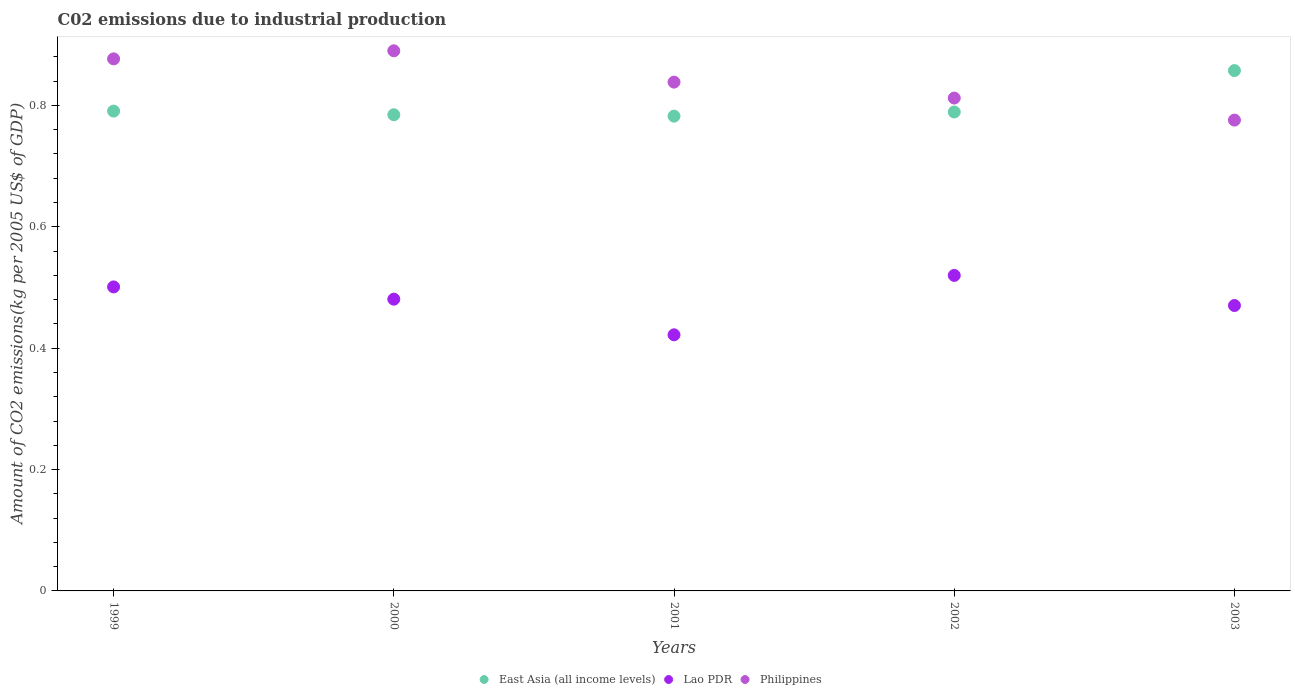Is the number of dotlines equal to the number of legend labels?
Make the answer very short. Yes. What is the amount of CO2 emitted due to industrial production in Philippines in 2000?
Your answer should be very brief. 0.89. Across all years, what is the maximum amount of CO2 emitted due to industrial production in East Asia (all income levels)?
Your answer should be compact. 0.86. Across all years, what is the minimum amount of CO2 emitted due to industrial production in Lao PDR?
Your response must be concise. 0.42. What is the total amount of CO2 emitted due to industrial production in Lao PDR in the graph?
Keep it short and to the point. 2.39. What is the difference between the amount of CO2 emitted due to industrial production in East Asia (all income levels) in 2000 and that in 2003?
Your response must be concise. -0.07. What is the difference between the amount of CO2 emitted due to industrial production in Lao PDR in 2002 and the amount of CO2 emitted due to industrial production in Philippines in 2000?
Offer a very short reply. -0.37. What is the average amount of CO2 emitted due to industrial production in Philippines per year?
Provide a short and direct response. 0.84. In the year 1999, what is the difference between the amount of CO2 emitted due to industrial production in Philippines and amount of CO2 emitted due to industrial production in East Asia (all income levels)?
Ensure brevity in your answer.  0.09. In how many years, is the amount of CO2 emitted due to industrial production in East Asia (all income levels) greater than 0.28 kg?
Your answer should be very brief. 5. What is the ratio of the amount of CO2 emitted due to industrial production in Philippines in 2000 to that in 2001?
Offer a very short reply. 1.06. Is the difference between the amount of CO2 emitted due to industrial production in Philippines in 2001 and 2002 greater than the difference between the amount of CO2 emitted due to industrial production in East Asia (all income levels) in 2001 and 2002?
Your answer should be compact. Yes. What is the difference between the highest and the second highest amount of CO2 emitted due to industrial production in East Asia (all income levels)?
Your answer should be very brief. 0.07. What is the difference between the highest and the lowest amount of CO2 emitted due to industrial production in East Asia (all income levels)?
Ensure brevity in your answer.  0.08. How many dotlines are there?
Your answer should be compact. 3. How many years are there in the graph?
Ensure brevity in your answer.  5. Are the values on the major ticks of Y-axis written in scientific E-notation?
Provide a short and direct response. No. Does the graph contain any zero values?
Offer a very short reply. No. Where does the legend appear in the graph?
Make the answer very short. Bottom center. How are the legend labels stacked?
Your answer should be compact. Horizontal. What is the title of the graph?
Keep it short and to the point. C02 emissions due to industrial production. What is the label or title of the X-axis?
Offer a terse response. Years. What is the label or title of the Y-axis?
Keep it short and to the point. Amount of CO2 emissions(kg per 2005 US$ of GDP). What is the Amount of CO2 emissions(kg per 2005 US$ of GDP) of East Asia (all income levels) in 1999?
Offer a very short reply. 0.79. What is the Amount of CO2 emissions(kg per 2005 US$ of GDP) of Lao PDR in 1999?
Provide a succinct answer. 0.5. What is the Amount of CO2 emissions(kg per 2005 US$ of GDP) of Philippines in 1999?
Your answer should be very brief. 0.88. What is the Amount of CO2 emissions(kg per 2005 US$ of GDP) of East Asia (all income levels) in 2000?
Offer a terse response. 0.78. What is the Amount of CO2 emissions(kg per 2005 US$ of GDP) in Lao PDR in 2000?
Give a very brief answer. 0.48. What is the Amount of CO2 emissions(kg per 2005 US$ of GDP) of Philippines in 2000?
Make the answer very short. 0.89. What is the Amount of CO2 emissions(kg per 2005 US$ of GDP) of East Asia (all income levels) in 2001?
Your answer should be very brief. 0.78. What is the Amount of CO2 emissions(kg per 2005 US$ of GDP) of Lao PDR in 2001?
Make the answer very short. 0.42. What is the Amount of CO2 emissions(kg per 2005 US$ of GDP) of Philippines in 2001?
Give a very brief answer. 0.84. What is the Amount of CO2 emissions(kg per 2005 US$ of GDP) of East Asia (all income levels) in 2002?
Your answer should be very brief. 0.79. What is the Amount of CO2 emissions(kg per 2005 US$ of GDP) in Lao PDR in 2002?
Your answer should be very brief. 0.52. What is the Amount of CO2 emissions(kg per 2005 US$ of GDP) of Philippines in 2002?
Give a very brief answer. 0.81. What is the Amount of CO2 emissions(kg per 2005 US$ of GDP) of East Asia (all income levels) in 2003?
Offer a terse response. 0.86. What is the Amount of CO2 emissions(kg per 2005 US$ of GDP) in Lao PDR in 2003?
Give a very brief answer. 0.47. What is the Amount of CO2 emissions(kg per 2005 US$ of GDP) in Philippines in 2003?
Make the answer very short. 0.78. Across all years, what is the maximum Amount of CO2 emissions(kg per 2005 US$ of GDP) in East Asia (all income levels)?
Your answer should be very brief. 0.86. Across all years, what is the maximum Amount of CO2 emissions(kg per 2005 US$ of GDP) of Lao PDR?
Offer a terse response. 0.52. Across all years, what is the maximum Amount of CO2 emissions(kg per 2005 US$ of GDP) in Philippines?
Your answer should be very brief. 0.89. Across all years, what is the minimum Amount of CO2 emissions(kg per 2005 US$ of GDP) in East Asia (all income levels)?
Your answer should be very brief. 0.78. Across all years, what is the minimum Amount of CO2 emissions(kg per 2005 US$ of GDP) of Lao PDR?
Your answer should be compact. 0.42. Across all years, what is the minimum Amount of CO2 emissions(kg per 2005 US$ of GDP) of Philippines?
Offer a very short reply. 0.78. What is the total Amount of CO2 emissions(kg per 2005 US$ of GDP) of East Asia (all income levels) in the graph?
Give a very brief answer. 4. What is the total Amount of CO2 emissions(kg per 2005 US$ of GDP) of Lao PDR in the graph?
Your answer should be very brief. 2.39. What is the total Amount of CO2 emissions(kg per 2005 US$ of GDP) of Philippines in the graph?
Give a very brief answer. 4.19. What is the difference between the Amount of CO2 emissions(kg per 2005 US$ of GDP) of East Asia (all income levels) in 1999 and that in 2000?
Offer a very short reply. 0.01. What is the difference between the Amount of CO2 emissions(kg per 2005 US$ of GDP) of Lao PDR in 1999 and that in 2000?
Ensure brevity in your answer.  0.02. What is the difference between the Amount of CO2 emissions(kg per 2005 US$ of GDP) of Philippines in 1999 and that in 2000?
Offer a very short reply. -0.01. What is the difference between the Amount of CO2 emissions(kg per 2005 US$ of GDP) of East Asia (all income levels) in 1999 and that in 2001?
Provide a succinct answer. 0.01. What is the difference between the Amount of CO2 emissions(kg per 2005 US$ of GDP) in Lao PDR in 1999 and that in 2001?
Offer a very short reply. 0.08. What is the difference between the Amount of CO2 emissions(kg per 2005 US$ of GDP) of Philippines in 1999 and that in 2001?
Provide a short and direct response. 0.04. What is the difference between the Amount of CO2 emissions(kg per 2005 US$ of GDP) of East Asia (all income levels) in 1999 and that in 2002?
Your response must be concise. 0. What is the difference between the Amount of CO2 emissions(kg per 2005 US$ of GDP) of Lao PDR in 1999 and that in 2002?
Your answer should be very brief. -0.02. What is the difference between the Amount of CO2 emissions(kg per 2005 US$ of GDP) of Philippines in 1999 and that in 2002?
Your answer should be compact. 0.06. What is the difference between the Amount of CO2 emissions(kg per 2005 US$ of GDP) of East Asia (all income levels) in 1999 and that in 2003?
Provide a short and direct response. -0.07. What is the difference between the Amount of CO2 emissions(kg per 2005 US$ of GDP) in Lao PDR in 1999 and that in 2003?
Your answer should be very brief. 0.03. What is the difference between the Amount of CO2 emissions(kg per 2005 US$ of GDP) of Philippines in 1999 and that in 2003?
Ensure brevity in your answer.  0.1. What is the difference between the Amount of CO2 emissions(kg per 2005 US$ of GDP) of East Asia (all income levels) in 2000 and that in 2001?
Make the answer very short. 0. What is the difference between the Amount of CO2 emissions(kg per 2005 US$ of GDP) in Lao PDR in 2000 and that in 2001?
Offer a very short reply. 0.06. What is the difference between the Amount of CO2 emissions(kg per 2005 US$ of GDP) of Philippines in 2000 and that in 2001?
Your answer should be compact. 0.05. What is the difference between the Amount of CO2 emissions(kg per 2005 US$ of GDP) in East Asia (all income levels) in 2000 and that in 2002?
Give a very brief answer. -0. What is the difference between the Amount of CO2 emissions(kg per 2005 US$ of GDP) in Lao PDR in 2000 and that in 2002?
Your response must be concise. -0.04. What is the difference between the Amount of CO2 emissions(kg per 2005 US$ of GDP) in Philippines in 2000 and that in 2002?
Keep it short and to the point. 0.08. What is the difference between the Amount of CO2 emissions(kg per 2005 US$ of GDP) in East Asia (all income levels) in 2000 and that in 2003?
Your response must be concise. -0.07. What is the difference between the Amount of CO2 emissions(kg per 2005 US$ of GDP) of Lao PDR in 2000 and that in 2003?
Give a very brief answer. 0.01. What is the difference between the Amount of CO2 emissions(kg per 2005 US$ of GDP) of Philippines in 2000 and that in 2003?
Your answer should be compact. 0.11. What is the difference between the Amount of CO2 emissions(kg per 2005 US$ of GDP) of East Asia (all income levels) in 2001 and that in 2002?
Offer a terse response. -0.01. What is the difference between the Amount of CO2 emissions(kg per 2005 US$ of GDP) of Lao PDR in 2001 and that in 2002?
Ensure brevity in your answer.  -0.1. What is the difference between the Amount of CO2 emissions(kg per 2005 US$ of GDP) in Philippines in 2001 and that in 2002?
Give a very brief answer. 0.03. What is the difference between the Amount of CO2 emissions(kg per 2005 US$ of GDP) of East Asia (all income levels) in 2001 and that in 2003?
Offer a very short reply. -0.08. What is the difference between the Amount of CO2 emissions(kg per 2005 US$ of GDP) in Lao PDR in 2001 and that in 2003?
Your answer should be very brief. -0.05. What is the difference between the Amount of CO2 emissions(kg per 2005 US$ of GDP) in Philippines in 2001 and that in 2003?
Make the answer very short. 0.06. What is the difference between the Amount of CO2 emissions(kg per 2005 US$ of GDP) in East Asia (all income levels) in 2002 and that in 2003?
Provide a succinct answer. -0.07. What is the difference between the Amount of CO2 emissions(kg per 2005 US$ of GDP) in Lao PDR in 2002 and that in 2003?
Provide a succinct answer. 0.05. What is the difference between the Amount of CO2 emissions(kg per 2005 US$ of GDP) in Philippines in 2002 and that in 2003?
Offer a very short reply. 0.04. What is the difference between the Amount of CO2 emissions(kg per 2005 US$ of GDP) of East Asia (all income levels) in 1999 and the Amount of CO2 emissions(kg per 2005 US$ of GDP) of Lao PDR in 2000?
Offer a very short reply. 0.31. What is the difference between the Amount of CO2 emissions(kg per 2005 US$ of GDP) in East Asia (all income levels) in 1999 and the Amount of CO2 emissions(kg per 2005 US$ of GDP) in Philippines in 2000?
Ensure brevity in your answer.  -0.1. What is the difference between the Amount of CO2 emissions(kg per 2005 US$ of GDP) in Lao PDR in 1999 and the Amount of CO2 emissions(kg per 2005 US$ of GDP) in Philippines in 2000?
Your answer should be very brief. -0.39. What is the difference between the Amount of CO2 emissions(kg per 2005 US$ of GDP) of East Asia (all income levels) in 1999 and the Amount of CO2 emissions(kg per 2005 US$ of GDP) of Lao PDR in 2001?
Ensure brevity in your answer.  0.37. What is the difference between the Amount of CO2 emissions(kg per 2005 US$ of GDP) of East Asia (all income levels) in 1999 and the Amount of CO2 emissions(kg per 2005 US$ of GDP) of Philippines in 2001?
Your response must be concise. -0.05. What is the difference between the Amount of CO2 emissions(kg per 2005 US$ of GDP) in Lao PDR in 1999 and the Amount of CO2 emissions(kg per 2005 US$ of GDP) in Philippines in 2001?
Offer a very short reply. -0.34. What is the difference between the Amount of CO2 emissions(kg per 2005 US$ of GDP) in East Asia (all income levels) in 1999 and the Amount of CO2 emissions(kg per 2005 US$ of GDP) in Lao PDR in 2002?
Your answer should be compact. 0.27. What is the difference between the Amount of CO2 emissions(kg per 2005 US$ of GDP) of East Asia (all income levels) in 1999 and the Amount of CO2 emissions(kg per 2005 US$ of GDP) of Philippines in 2002?
Give a very brief answer. -0.02. What is the difference between the Amount of CO2 emissions(kg per 2005 US$ of GDP) in Lao PDR in 1999 and the Amount of CO2 emissions(kg per 2005 US$ of GDP) in Philippines in 2002?
Keep it short and to the point. -0.31. What is the difference between the Amount of CO2 emissions(kg per 2005 US$ of GDP) in East Asia (all income levels) in 1999 and the Amount of CO2 emissions(kg per 2005 US$ of GDP) in Lao PDR in 2003?
Provide a short and direct response. 0.32. What is the difference between the Amount of CO2 emissions(kg per 2005 US$ of GDP) in East Asia (all income levels) in 1999 and the Amount of CO2 emissions(kg per 2005 US$ of GDP) in Philippines in 2003?
Your answer should be very brief. 0.01. What is the difference between the Amount of CO2 emissions(kg per 2005 US$ of GDP) of Lao PDR in 1999 and the Amount of CO2 emissions(kg per 2005 US$ of GDP) of Philippines in 2003?
Provide a short and direct response. -0.27. What is the difference between the Amount of CO2 emissions(kg per 2005 US$ of GDP) in East Asia (all income levels) in 2000 and the Amount of CO2 emissions(kg per 2005 US$ of GDP) in Lao PDR in 2001?
Your answer should be very brief. 0.36. What is the difference between the Amount of CO2 emissions(kg per 2005 US$ of GDP) of East Asia (all income levels) in 2000 and the Amount of CO2 emissions(kg per 2005 US$ of GDP) of Philippines in 2001?
Your answer should be very brief. -0.05. What is the difference between the Amount of CO2 emissions(kg per 2005 US$ of GDP) in Lao PDR in 2000 and the Amount of CO2 emissions(kg per 2005 US$ of GDP) in Philippines in 2001?
Make the answer very short. -0.36. What is the difference between the Amount of CO2 emissions(kg per 2005 US$ of GDP) of East Asia (all income levels) in 2000 and the Amount of CO2 emissions(kg per 2005 US$ of GDP) of Lao PDR in 2002?
Offer a terse response. 0.26. What is the difference between the Amount of CO2 emissions(kg per 2005 US$ of GDP) in East Asia (all income levels) in 2000 and the Amount of CO2 emissions(kg per 2005 US$ of GDP) in Philippines in 2002?
Make the answer very short. -0.03. What is the difference between the Amount of CO2 emissions(kg per 2005 US$ of GDP) in Lao PDR in 2000 and the Amount of CO2 emissions(kg per 2005 US$ of GDP) in Philippines in 2002?
Offer a very short reply. -0.33. What is the difference between the Amount of CO2 emissions(kg per 2005 US$ of GDP) of East Asia (all income levels) in 2000 and the Amount of CO2 emissions(kg per 2005 US$ of GDP) of Lao PDR in 2003?
Make the answer very short. 0.31. What is the difference between the Amount of CO2 emissions(kg per 2005 US$ of GDP) of East Asia (all income levels) in 2000 and the Amount of CO2 emissions(kg per 2005 US$ of GDP) of Philippines in 2003?
Offer a very short reply. 0.01. What is the difference between the Amount of CO2 emissions(kg per 2005 US$ of GDP) in Lao PDR in 2000 and the Amount of CO2 emissions(kg per 2005 US$ of GDP) in Philippines in 2003?
Keep it short and to the point. -0.3. What is the difference between the Amount of CO2 emissions(kg per 2005 US$ of GDP) in East Asia (all income levels) in 2001 and the Amount of CO2 emissions(kg per 2005 US$ of GDP) in Lao PDR in 2002?
Provide a succinct answer. 0.26. What is the difference between the Amount of CO2 emissions(kg per 2005 US$ of GDP) of East Asia (all income levels) in 2001 and the Amount of CO2 emissions(kg per 2005 US$ of GDP) of Philippines in 2002?
Ensure brevity in your answer.  -0.03. What is the difference between the Amount of CO2 emissions(kg per 2005 US$ of GDP) of Lao PDR in 2001 and the Amount of CO2 emissions(kg per 2005 US$ of GDP) of Philippines in 2002?
Give a very brief answer. -0.39. What is the difference between the Amount of CO2 emissions(kg per 2005 US$ of GDP) in East Asia (all income levels) in 2001 and the Amount of CO2 emissions(kg per 2005 US$ of GDP) in Lao PDR in 2003?
Keep it short and to the point. 0.31. What is the difference between the Amount of CO2 emissions(kg per 2005 US$ of GDP) of East Asia (all income levels) in 2001 and the Amount of CO2 emissions(kg per 2005 US$ of GDP) of Philippines in 2003?
Offer a very short reply. 0.01. What is the difference between the Amount of CO2 emissions(kg per 2005 US$ of GDP) of Lao PDR in 2001 and the Amount of CO2 emissions(kg per 2005 US$ of GDP) of Philippines in 2003?
Provide a succinct answer. -0.35. What is the difference between the Amount of CO2 emissions(kg per 2005 US$ of GDP) of East Asia (all income levels) in 2002 and the Amount of CO2 emissions(kg per 2005 US$ of GDP) of Lao PDR in 2003?
Your answer should be very brief. 0.32. What is the difference between the Amount of CO2 emissions(kg per 2005 US$ of GDP) of East Asia (all income levels) in 2002 and the Amount of CO2 emissions(kg per 2005 US$ of GDP) of Philippines in 2003?
Your answer should be compact. 0.01. What is the difference between the Amount of CO2 emissions(kg per 2005 US$ of GDP) in Lao PDR in 2002 and the Amount of CO2 emissions(kg per 2005 US$ of GDP) in Philippines in 2003?
Provide a short and direct response. -0.26. What is the average Amount of CO2 emissions(kg per 2005 US$ of GDP) of East Asia (all income levels) per year?
Provide a short and direct response. 0.8. What is the average Amount of CO2 emissions(kg per 2005 US$ of GDP) of Lao PDR per year?
Offer a very short reply. 0.48. What is the average Amount of CO2 emissions(kg per 2005 US$ of GDP) in Philippines per year?
Provide a succinct answer. 0.84. In the year 1999, what is the difference between the Amount of CO2 emissions(kg per 2005 US$ of GDP) of East Asia (all income levels) and Amount of CO2 emissions(kg per 2005 US$ of GDP) of Lao PDR?
Your response must be concise. 0.29. In the year 1999, what is the difference between the Amount of CO2 emissions(kg per 2005 US$ of GDP) in East Asia (all income levels) and Amount of CO2 emissions(kg per 2005 US$ of GDP) in Philippines?
Keep it short and to the point. -0.09. In the year 1999, what is the difference between the Amount of CO2 emissions(kg per 2005 US$ of GDP) of Lao PDR and Amount of CO2 emissions(kg per 2005 US$ of GDP) of Philippines?
Your response must be concise. -0.38. In the year 2000, what is the difference between the Amount of CO2 emissions(kg per 2005 US$ of GDP) in East Asia (all income levels) and Amount of CO2 emissions(kg per 2005 US$ of GDP) in Lao PDR?
Provide a short and direct response. 0.3. In the year 2000, what is the difference between the Amount of CO2 emissions(kg per 2005 US$ of GDP) in East Asia (all income levels) and Amount of CO2 emissions(kg per 2005 US$ of GDP) in Philippines?
Your answer should be very brief. -0.11. In the year 2000, what is the difference between the Amount of CO2 emissions(kg per 2005 US$ of GDP) in Lao PDR and Amount of CO2 emissions(kg per 2005 US$ of GDP) in Philippines?
Ensure brevity in your answer.  -0.41. In the year 2001, what is the difference between the Amount of CO2 emissions(kg per 2005 US$ of GDP) in East Asia (all income levels) and Amount of CO2 emissions(kg per 2005 US$ of GDP) in Lao PDR?
Give a very brief answer. 0.36. In the year 2001, what is the difference between the Amount of CO2 emissions(kg per 2005 US$ of GDP) of East Asia (all income levels) and Amount of CO2 emissions(kg per 2005 US$ of GDP) of Philippines?
Give a very brief answer. -0.06. In the year 2001, what is the difference between the Amount of CO2 emissions(kg per 2005 US$ of GDP) in Lao PDR and Amount of CO2 emissions(kg per 2005 US$ of GDP) in Philippines?
Make the answer very short. -0.42. In the year 2002, what is the difference between the Amount of CO2 emissions(kg per 2005 US$ of GDP) in East Asia (all income levels) and Amount of CO2 emissions(kg per 2005 US$ of GDP) in Lao PDR?
Offer a very short reply. 0.27. In the year 2002, what is the difference between the Amount of CO2 emissions(kg per 2005 US$ of GDP) in East Asia (all income levels) and Amount of CO2 emissions(kg per 2005 US$ of GDP) in Philippines?
Make the answer very short. -0.02. In the year 2002, what is the difference between the Amount of CO2 emissions(kg per 2005 US$ of GDP) in Lao PDR and Amount of CO2 emissions(kg per 2005 US$ of GDP) in Philippines?
Provide a short and direct response. -0.29. In the year 2003, what is the difference between the Amount of CO2 emissions(kg per 2005 US$ of GDP) in East Asia (all income levels) and Amount of CO2 emissions(kg per 2005 US$ of GDP) in Lao PDR?
Your answer should be compact. 0.39. In the year 2003, what is the difference between the Amount of CO2 emissions(kg per 2005 US$ of GDP) of East Asia (all income levels) and Amount of CO2 emissions(kg per 2005 US$ of GDP) of Philippines?
Your answer should be compact. 0.08. In the year 2003, what is the difference between the Amount of CO2 emissions(kg per 2005 US$ of GDP) in Lao PDR and Amount of CO2 emissions(kg per 2005 US$ of GDP) in Philippines?
Provide a short and direct response. -0.31. What is the ratio of the Amount of CO2 emissions(kg per 2005 US$ of GDP) of East Asia (all income levels) in 1999 to that in 2000?
Give a very brief answer. 1.01. What is the ratio of the Amount of CO2 emissions(kg per 2005 US$ of GDP) of Lao PDR in 1999 to that in 2000?
Provide a succinct answer. 1.04. What is the ratio of the Amount of CO2 emissions(kg per 2005 US$ of GDP) in East Asia (all income levels) in 1999 to that in 2001?
Give a very brief answer. 1.01. What is the ratio of the Amount of CO2 emissions(kg per 2005 US$ of GDP) in Lao PDR in 1999 to that in 2001?
Provide a succinct answer. 1.19. What is the ratio of the Amount of CO2 emissions(kg per 2005 US$ of GDP) in Philippines in 1999 to that in 2001?
Offer a very short reply. 1.05. What is the ratio of the Amount of CO2 emissions(kg per 2005 US$ of GDP) of East Asia (all income levels) in 1999 to that in 2002?
Your answer should be compact. 1. What is the ratio of the Amount of CO2 emissions(kg per 2005 US$ of GDP) in Lao PDR in 1999 to that in 2002?
Your answer should be very brief. 0.96. What is the ratio of the Amount of CO2 emissions(kg per 2005 US$ of GDP) of Philippines in 1999 to that in 2002?
Make the answer very short. 1.08. What is the ratio of the Amount of CO2 emissions(kg per 2005 US$ of GDP) of East Asia (all income levels) in 1999 to that in 2003?
Make the answer very short. 0.92. What is the ratio of the Amount of CO2 emissions(kg per 2005 US$ of GDP) of Lao PDR in 1999 to that in 2003?
Offer a terse response. 1.07. What is the ratio of the Amount of CO2 emissions(kg per 2005 US$ of GDP) in Philippines in 1999 to that in 2003?
Your response must be concise. 1.13. What is the ratio of the Amount of CO2 emissions(kg per 2005 US$ of GDP) in East Asia (all income levels) in 2000 to that in 2001?
Give a very brief answer. 1. What is the ratio of the Amount of CO2 emissions(kg per 2005 US$ of GDP) in Lao PDR in 2000 to that in 2001?
Give a very brief answer. 1.14. What is the ratio of the Amount of CO2 emissions(kg per 2005 US$ of GDP) of Philippines in 2000 to that in 2001?
Give a very brief answer. 1.06. What is the ratio of the Amount of CO2 emissions(kg per 2005 US$ of GDP) of Lao PDR in 2000 to that in 2002?
Provide a succinct answer. 0.92. What is the ratio of the Amount of CO2 emissions(kg per 2005 US$ of GDP) in Philippines in 2000 to that in 2002?
Give a very brief answer. 1.1. What is the ratio of the Amount of CO2 emissions(kg per 2005 US$ of GDP) in East Asia (all income levels) in 2000 to that in 2003?
Provide a succinct answer. 0.92. What is the ratio of the Amount of CO2 emissions(kg per 2005 US$ of GDP) in Lao PDR in 2000 to that in 2003?
Provide a succinct answer. 1.02. What is the ratio of the Amount of CO2 emissions(kg per 2005 US$ of GDP) of Philippines in 2000 to that in 2003?
Your answer should be very brief. 1.15. What is the ratio of the Amount of CO2 emissions(kg per 2005 US$ of GDP) of East Asia (all income levels) in 2001 to that in 2002?
Give a very brief answer. 0.99. What is the ratio of the Amount of CO2 emissions(kg per 2005 US$ of GDP) in Lao PDR in 2001 to that in 2002?
Keep it short and to the point. 0.81. What is the ratio of the Amount of CO2 emissions(kg per 2005 US$ of GDP) in Philippines in 2001 to that in 2002?
Offer a terse response. 1.03. What is the ratio of the Amount of CO2 emissions(kg per 2005 US$ of GDP) of East Asia (all income levels) in 2001 to that in 2003?
Your answer should be very brief. 0.91. What is the ratio of the Amount of CO2 emissions(kg per 2005 US$ of GDP) of Lao PDR in 2001 to that in 2003?
Your answer should be very brief. 0.9. What is the ratio of the Amount of CO2 emissions(kg per 2005 US$ of GDP) in Philippines in 2001 to that in 2003?
Offer a very short reply. 1.08. What is the ratio of the Amount of CO2 emissions(kg per 2005 US$ of GDP) of East Asia (all income levels) in 2002 to that in 2003?
Your answer should be very brief. 0.92. What is the ratio of the Amount of CO2 emissions(kg per 2005 US$ of GDP) in Lao PDR in 2002 to that in 2003?
Ensure brevity in your answer.  1.11. What is the ratio of the Amount of CO2 emissions(kg per 2005 US$ of GDP) in Philippines in 2002 to that in 2003?
Your answer should be compact. 1.05. What is the difference between the highest and the second highest Amount of CO2 emissions(kg per 2005 US$ of GDP) of East Asia (all income levels)?
Offer a very short reply. 0.07. What is the difference between the highest and the second highest Amount of CO2 emissions(kg per 2005 US$ of GDP) in Lao PDR?
Your answer should be very brief. 0.02. What is the difference between the highest and the second highest Amount of CO2 emissions(kg per 2005 US$ of GDP) of Philippines?
Your answer should be compact. 0.01. What is the difference between the highest and the lowest Amount of CO2 emissions(kg per 2005 US$ of GDP) of East Asia (all income levels)?
Make the answer very short. 0.08. What is the difference between the highest and the lowest Amount of CO2 emissions(kg per 2005 US$ of GDP) of Lao PDR?
Make the answer very short. 0.1. What is the difference between the highest and the lowest Amount of CO2 emissions(kg per 2005 US$ of GDP) in Philippines?
Provide a short and direct response. 0.11. 